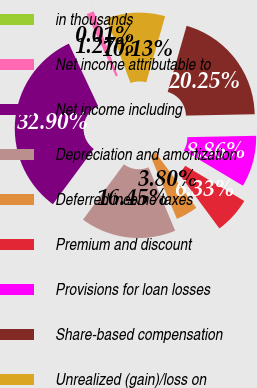Convert chart. <chart><loc_0><loc_0><loc_500><loc_500><pie_chart><fcel>in thousands<fcel>Net income attributable to<fcel>Net income including<fcel>Depreciation and amortization<fcel>Deferred income taxes<fcel>Premium and discount<fcel>Provisions for loan losses<fcel>Share-based compensation<fcel>Unrealized (gain)/loss on<nl><fcel>0.01%<fcel>1.27%<fcel>32.9%<fcel>16.45%<fcel>3.8%<fcel>6.33%<fcel>8.86%<fcel>20.25%<fcel>10.13%<nl></chart> 